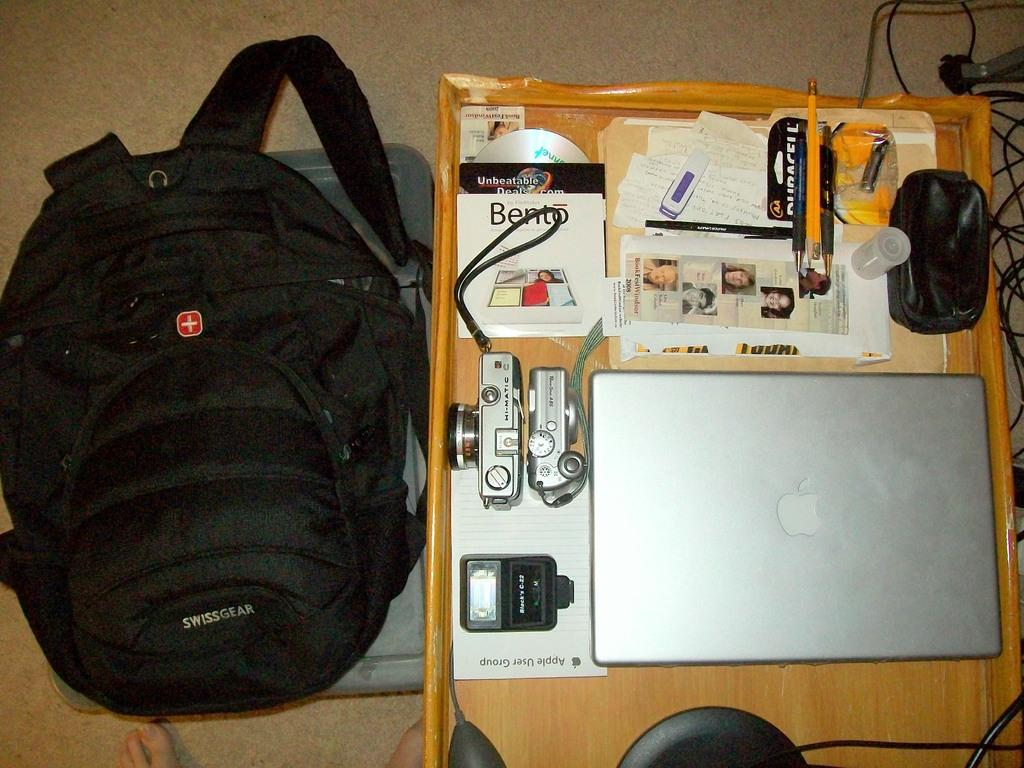<image>
Relay a brief, clear account of the picture shown. A computer sits on a small table near an Unbeatable Deals advertisement. 